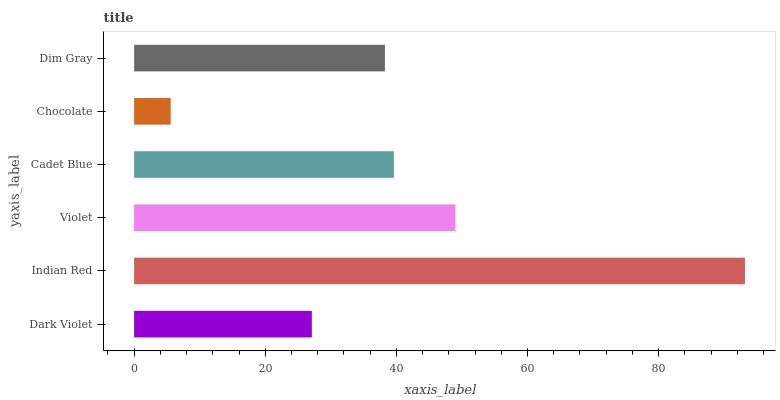Is Chocolate the minimum?
Answer yes or no. Yes. Is Indian Red the maximum?
Answer yes or no. Yes. Is Violet the minimum?
Answer yes or no. No. Is Violet the maximum?
Answer yes or no. No. Is Indian Red greater than Violet?
Answer yes or no. Yes. Is Violet less than Indian Red?
Answer yes or no. Yes. Is Violet greater than Indian Red?
Answer yes or no. No. Is Indian Red less than Violet?
Answer yes or no. No. Is Cadet Blue the high median?
Answer yes or no. Yes. Is Dim Gray the low median?
Answer yes or no. Yes. Is Violet the high median?
Answer yes or no. No. Is Chocolate the low median?
Answer yes or no. No. 